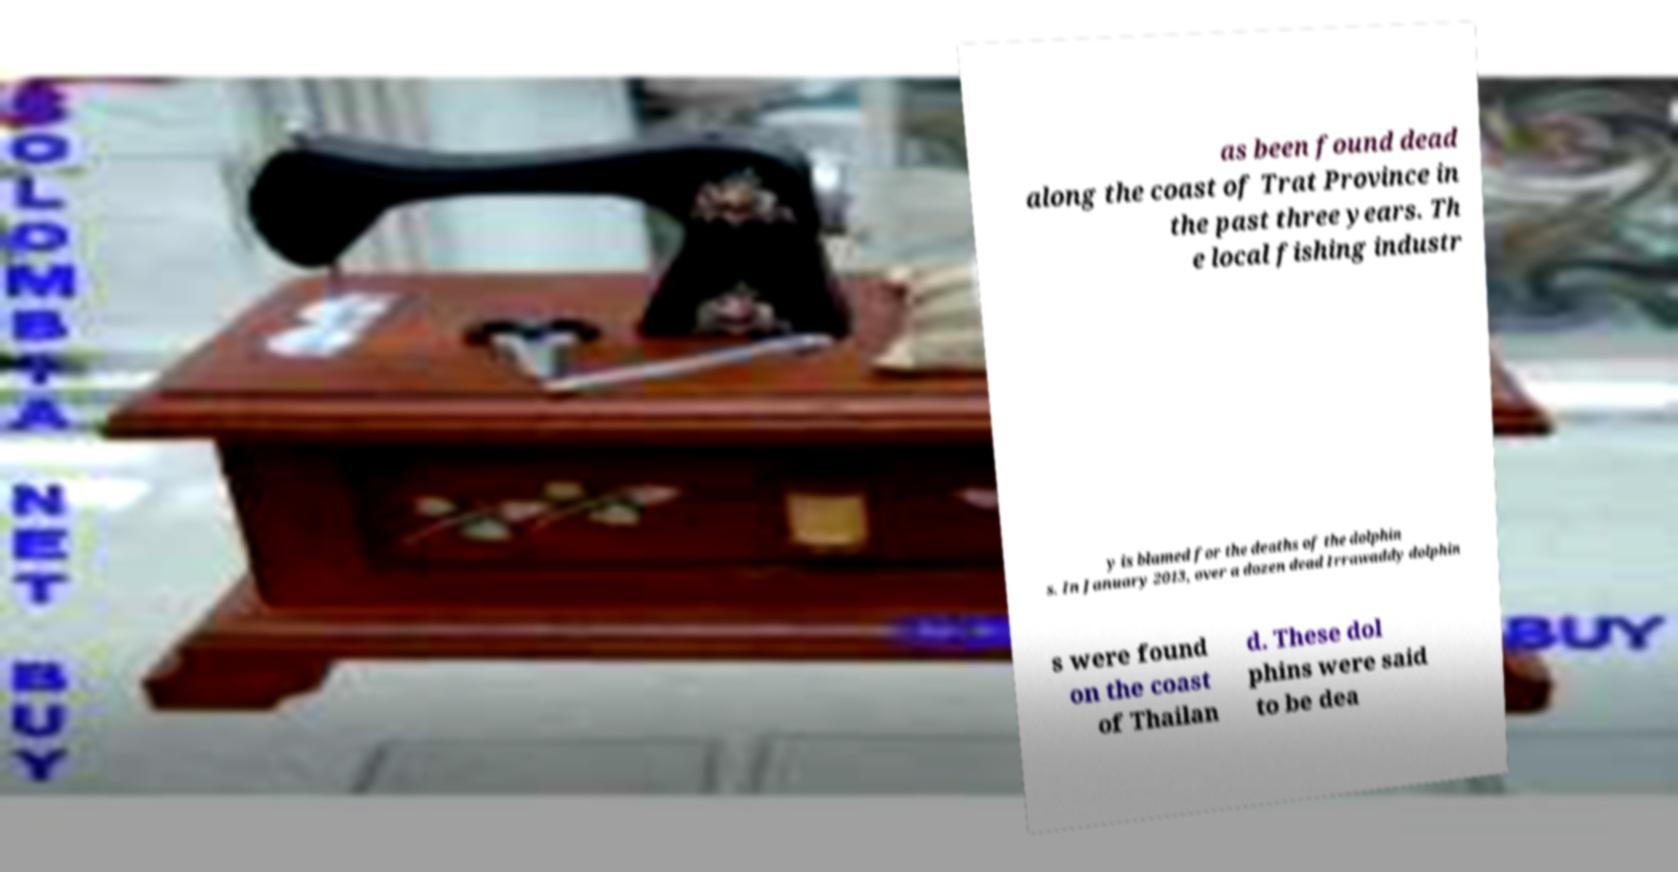Please read and relay the text visible in this image. What does it say? as been found dead along the coast of Trat Province in the past three years. Th e local fishing industr y is blamed for the deaths of the dolphin s. In January 2013, over a dozen dead Irrawaddy dolphin s were found on the coast of Thailan d. These dol phins were said to be dea 